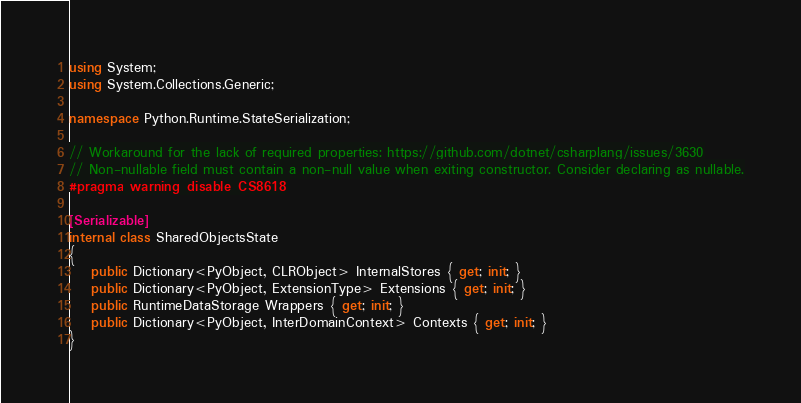<code> <loc_0><loc_0><loc_500><loc_500><_C#_>using System;
using System.Collections.Generic;

namespace Python.Runtime.StateSerialization;

// Workaround for the lack of required properties: https://github.com/dotnet/csharplang/issues/3630
// Non-nullable field must contain a non-null value when exiting constructor. Consider declaring as nullable.
#pragma warning disable CS8618

[Serializable]
internal class SharedObjectsState
{
    public Dictionary<PyObject, CLRObject> InternalStores { get; init; }
    public Dictionary<PyObject, ExtensionType> Extensions { get; init; }
    public RuntimeDataStorage Wrappers { get; init; }
    public Dictionary<PyObject, InterDomainContext> Contexts { get; init; }
}
</code> 